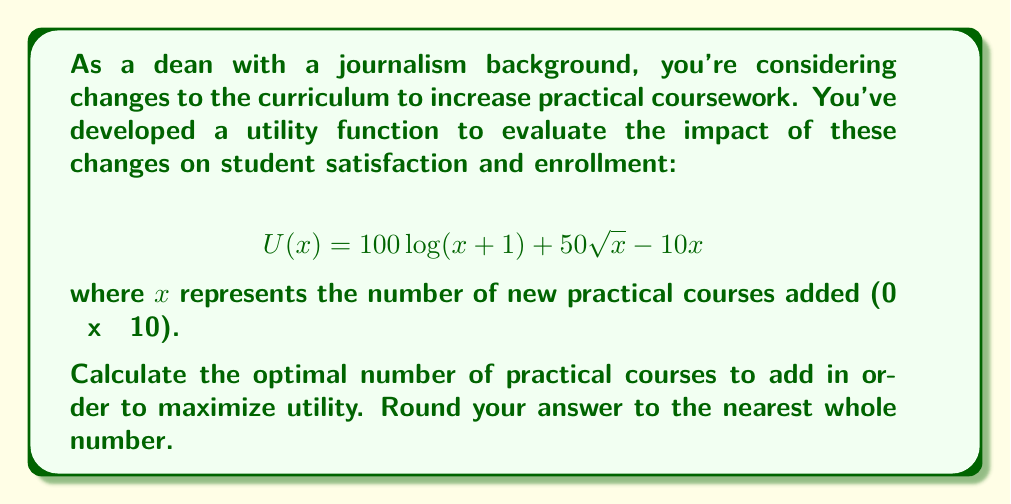What is the answer to this math problem? To find the optimal number of practical courses that maximizes utility, we need to find the maximum value of the utility function $U(x)$ within the given range of $x$ (0 ≤ x ≤ 10).

1. First, let's find the derivative of $U(x)$:

   $$U'(x) = \frac{100}{x+1} + \frac{25}{\sqrt{x}} - 10$$

2. To find the maximum, we set $U'(x) = 0$ and solve for $x$:

   $$\frac{100}{x+1} + \frac{25}{\sqrt{x}} - 10 = 0$$

3. This equation is difficult to solve analytically, so we'll use numerical methods to approximate the solution.

4. Using a graphing calculator or computer software, we can plot $U'(x)$ and find where it crosses the x-axis. This occurs at approximately $x = 3.62$.

5. To verify this is a maximum, we can check the second derivative:

   $$U''(x) = -\frac{100}{(x+1)^2} - \frac{25}{4x^{3/2}}$$

   This is always negative for $x > 0$, confirming that our solution is a maximum.

6. Since we need to round to the nearest whole number, we should compare $U(3)$ and $U(4)$:

   $U(3) = 100\log(4) + 50\sqrt{3} - 10(3) = 238.66$
   $U(4) = 100\log(5) + 50\sqrt{4} - 10(4) = 240.94$

7. Therefore, the rounded optimal solution is 4 practical courses.
Answer: 4 practical courses 